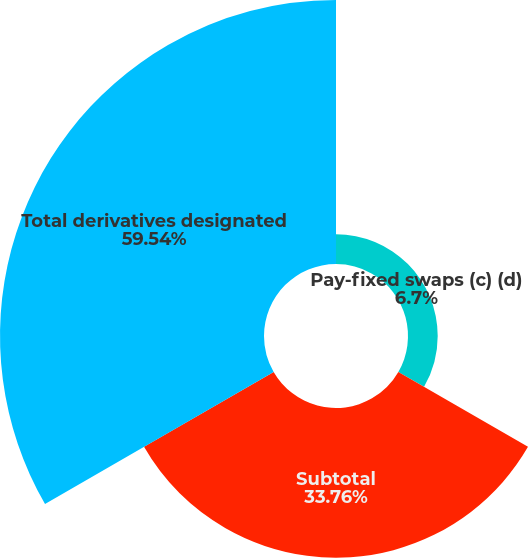Convert chart. <chart><loc_0><loc_0><loc_500><loc_500><pie_chart><fcel>Pay-fixed swaps (c) (d)<fcel>Subtotal<fcel>Total derivatives designated<nl><fcel>6.7%<fcel>33.76%<fcel>59.54%<nl></chart> 